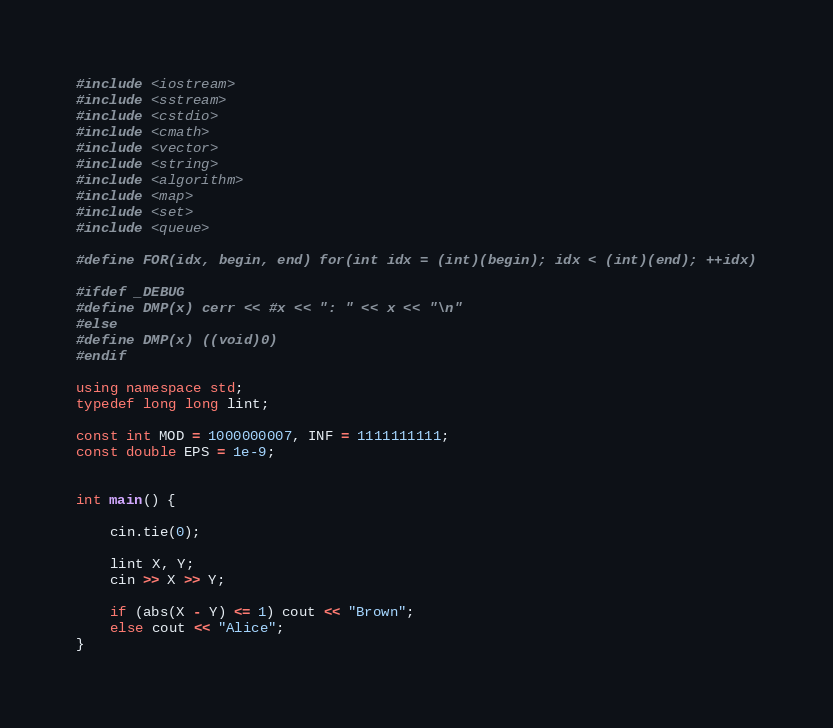Convert code to text. <code><loc_0><loc_0><loc_500><loc_500><_C++_>#include <iostream>
#include <sstream>
#include <cstdio>
#include <cmath>
#include <vector>
#include <string>
#include <algorithm>
#include <map>
#include <set>
#include <queue>

#define FOR(idx, begin, end) for(int idx = (int)(begin); idx < (int)(end); ++idx)

#ifdef _DEBUG
#define DMP(x) cerr << #x << ": " << x << "\n"
#else
#define DMP(x) ((void)0)
#endif

using namespace std;
typedef long long lint;

const int MOD = 1000000007, INF = 1111111111;
const double EPS = 1e-9;


int main() {

	cin.tie(0);

	lint X, Y;
	cin >> X >> Y;

	if (abs(X - Y) <= 1) cout << "Brown";
	else cout << "Alice";
}</code> 